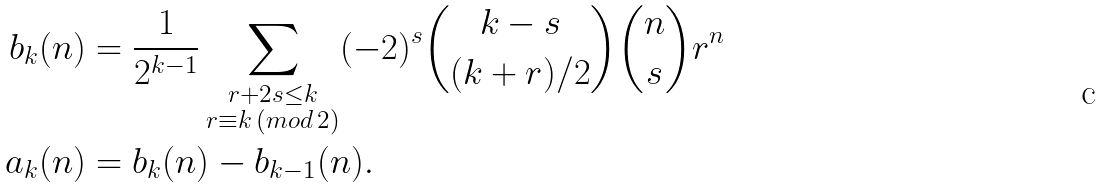<formula> <loc_0><loc_0><loc_500><loc_500>b _ { k } ( n ) & = \frac { 1 } { 2 ^ { k - 1 } } \sum _ { \substack { r + 2 s \leq k \\ r \equiv k \, ( m o d \, 2 ) } } ( - 2 ) ^ { s } \binom { k - s } { ( k + r ) / 2 } \binom { n } { s } r ^ { n } \\ a _ { k } ( n ) & = b _ { k } ( n ) - b _ { k - 1 } ( n ) .</formula> 